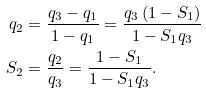Convert formula to latex. <formula><loc_0><loc_0><loc_500><loc_500>q _ { 2 } & = \frac { q _ { 3 } - q _ { 1 } } { 1 - q _ { 1 } } = \frac { q _ { 3 } \left ( 1 - S _ { 1 } \right ) } { 1 - S _ { 1 } q _ { 3 } } \\ S _ { 2 } & = \frac { q _ { 2 } } { q _ { 3 } } = \frac { 1 - S _ { 1 } } { 1 - S _ { 1 } q _ { 3 } } .</formula> 